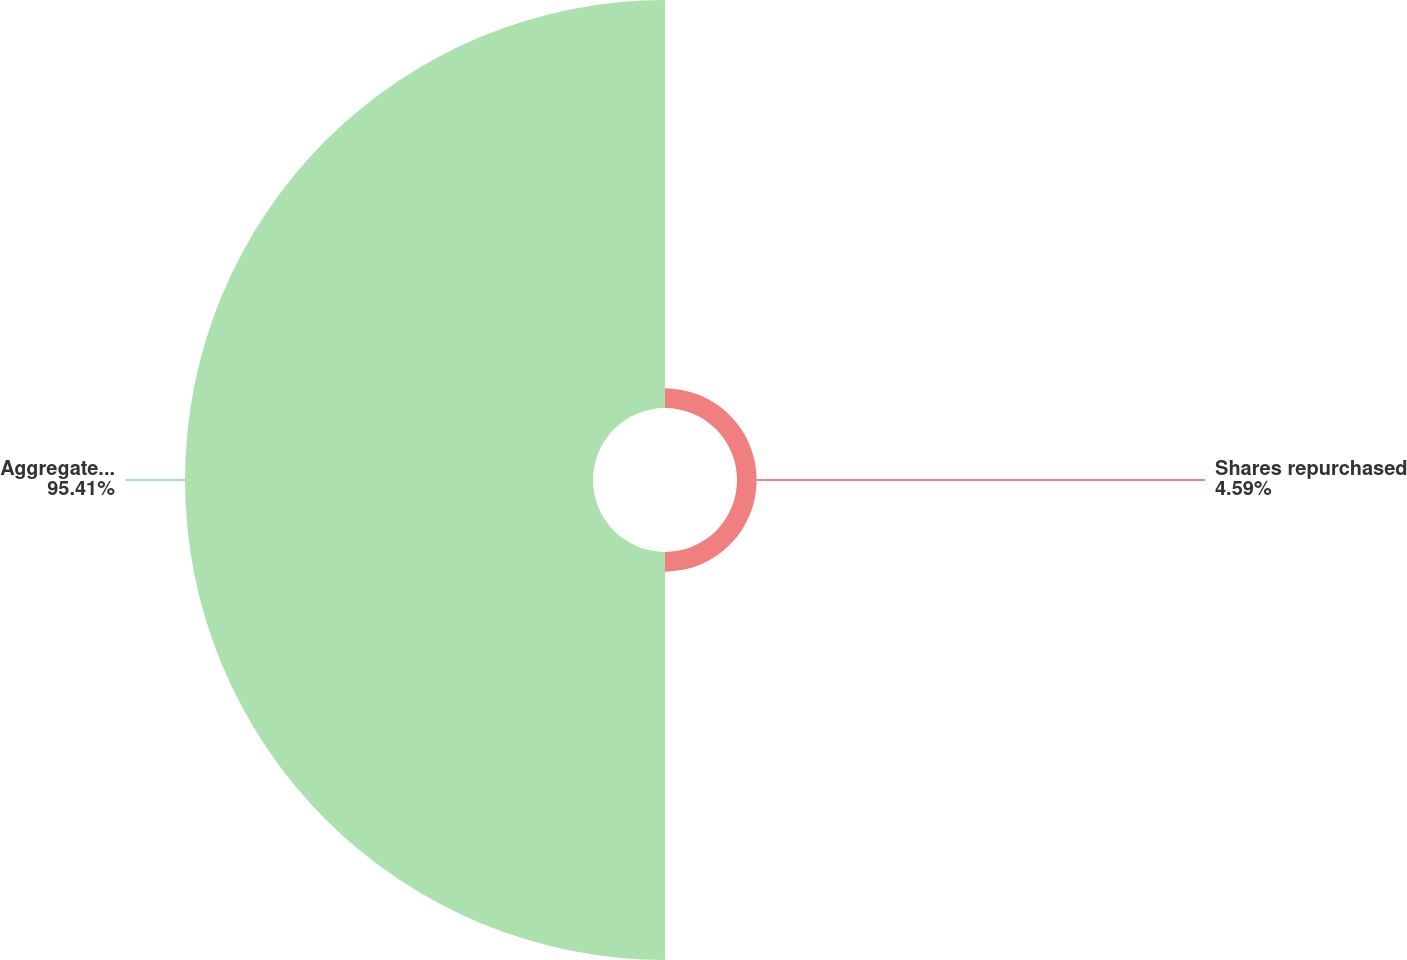Convert chart. <chart><loc_0><loc_0><loc_500><loc_500><pie_chart><fcel>Shares repurchased<fcel>Aggregate purchase price<nl><fcel>4.59%<fcel>95.41%<nl></chart> 